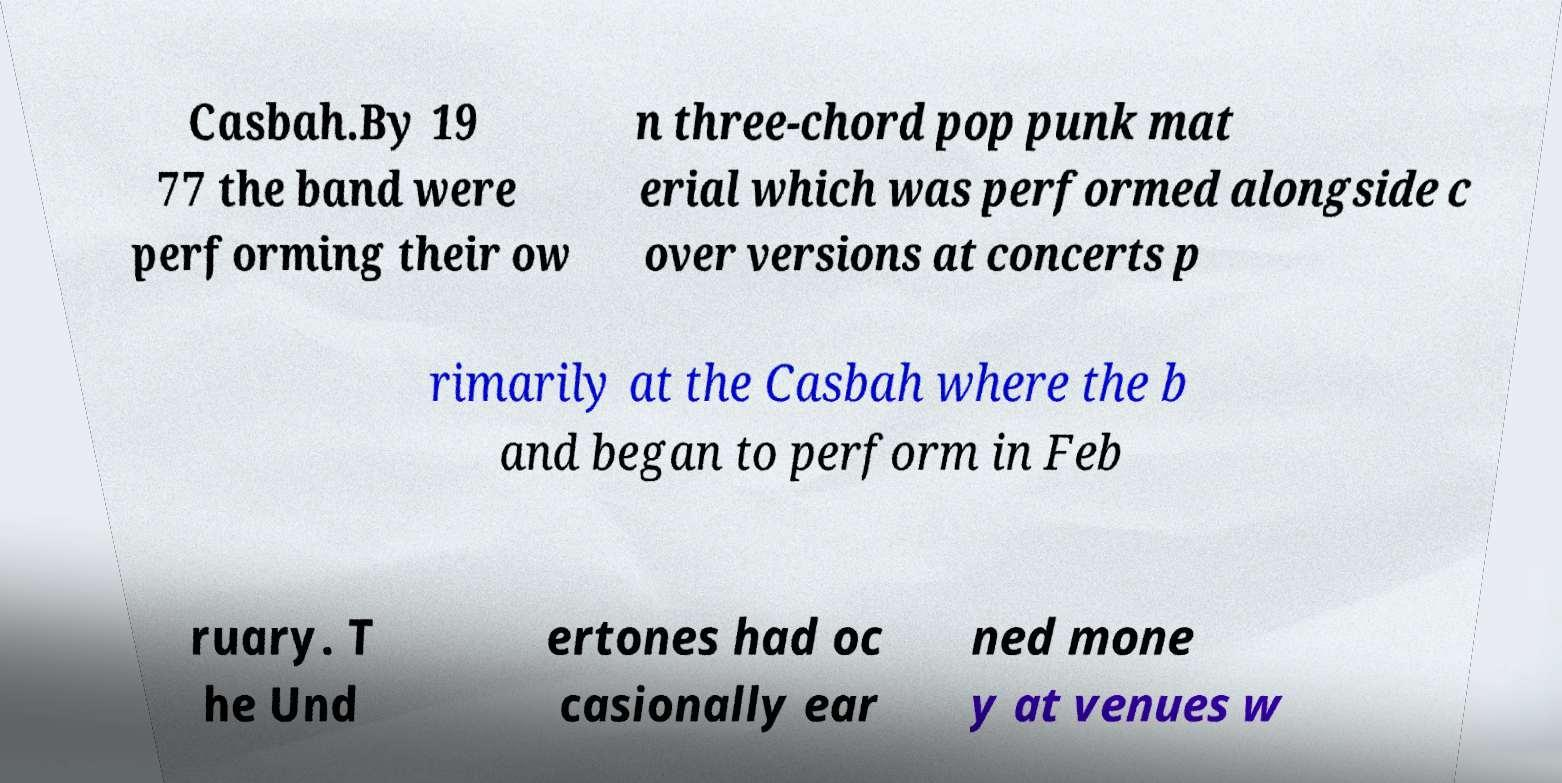There's text embedded in this image that I need extracted. Can you transcribe it verbatim? Casbah.By 19 77 the band were performing their ow n three-chord pop punk mat erial which was performed alongside c over versions at concerts p rimarily at the Casbah where the b and began to perform in Feb ruary. T he Und ertones had oc casionally ear ned mone y at venues w 